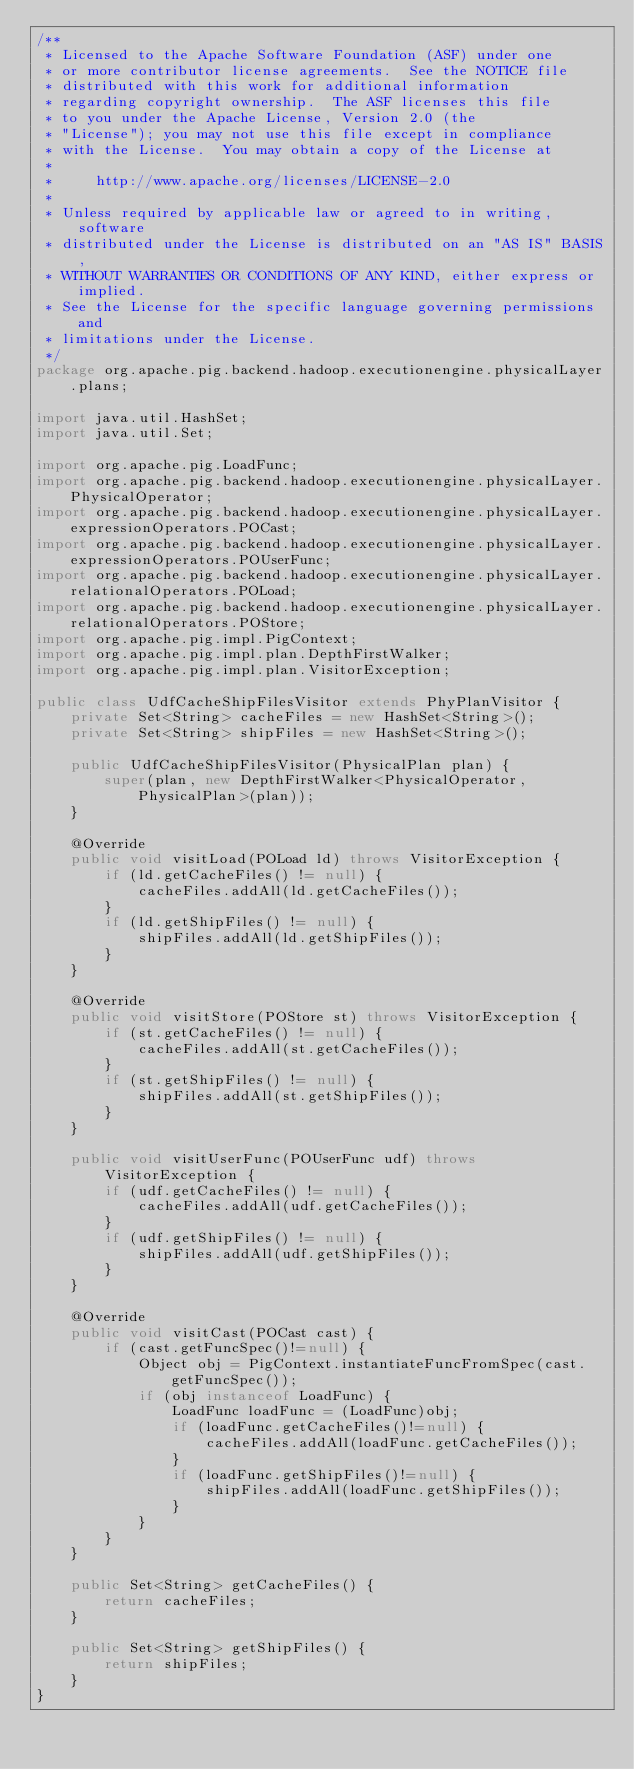Convert code to text. <code><loc_0><loc_0><loc_500><loc_500><_Java_>/**
 * Licensed to the Apache Software Foundation (ASF) under one
 * or more contributor license agreements.  See the NOTICE file
 * distributed with this work for additional information
 * regarding copyright ownership.  The ASF licenses this file
 * to you under the Apache License, Version 2.0 (the
 * "License"); you may not use this file except in compliance
 * with the License.  You may obtain a copy of the License at
 *
 *     http://www.apache.org/licenses/LICENSE-2.0
 *
 * Unless required by applicable law or agreed to in writing, software
 * distributed under the License is distributed on an "AS IS" BASIS,
 * WITHOUT WARRANTIES OR CONDITIONS OF ANY KIND, either express or implied.
 * See the License for the specific language governing permissions and
 * limitations under the License.
 */
package org.apache.pig.backend.hadoop.executionengine.physicalLayer.plans;

import java.util.HashSet;
import java.util.Set;

import org.apache.pig.LoadFunc;
import org.apache.pig.backend.hadoop.executionengine.physicalLayer.PhysicalOperator;
import org.apache.pig.backend.hadoop.executionengine.physicalLayer.expressionOperators.POCast;
import org.apache.pig.backend.hadoop.executionengine.physicalLayer.expressionOperators.POUserFunc;
import org.apache.pig.backend.hadoop.executionengine.physicalLayer.relationalOperators.POLoad;
import org.apache.pig.backend.hadoop.executionengine.physicalLayer.relationalOperators.POStore;
import org.apache.pig.impl.PigContext;
import org.apache.pig.impl.plan.DepthFirstWalker;
import org.apache.pig.impl.plan.VisitorException;

public class UdfCacheShipFilesVisitor extends PhyPlanVisitor {
    private Set<String> cacheFiles = new HashSet<String>();
    private Set<String> shipFiles = new HashSet<String>();

    public UdfCacheShipFilesVisitor(PhysicalPlan plan) {
        super(plan, new DepthFirstWalker<PhysicalOperator, PhysicalPlan>(plan));
    }

    @Override
    public void visitLoad(POLoad ld) throws VisitorException {
        if (ld.getCacheFiles() != null) {
            cacheFiles.addAll(ld.getCacheFiles());
        }
        if (ld.getShipFiles() != null) {
            shipFiles.addAll(ld.getShipFiles());
        }
    }

    @Override
    public void visitStore(POStore st) throws VisitorException {
        if (st.getCacheFiles() != null) {
            cacheFiles.addAll(st.getCacheFiles());
        }
        if (st.getShipFiles() != null) {
            shipFiles.addAll(st.getShipFiles());
        }
    }

    public void visitUserFunc(POUserFunc udf) throws VisitorException {
        if (udf.getCacheFiles() != null) {
            cacheFiles.addAll(udf.getCacheFiles());
        }
        if (udf.getShipFiles() != null) {
            shipFiles.addAll(udf.getShipFiles());
        }
    }

    @Override
    public void visitCast(POCast cast) {
        if (cast.getFuncSpec()!=null) {
            Object obj = PigContext.instantiateFuncFromSpec(cast.getFuncSpec());
            if (obj instanceof LoadFunc) {
                LoadFunc loadFunc = (LoadFunc)obj;
                if (loadFunc.getCacheFiles()!=null) {
                    cacheFiles.addAll(loadFunc.getCacheFiles());
                }
                if (loadFunc.getShipFiles()!=null) {
                    shipFiles.addAll(loadFunc.getShipFiles());
                }
            }
        }
    }

    public Set<String> getCacheFiles() {
        return cacheFiles;
    }

    public Set<String> getShipFiles() {
        return shipFiles;
    }
}
</code> 